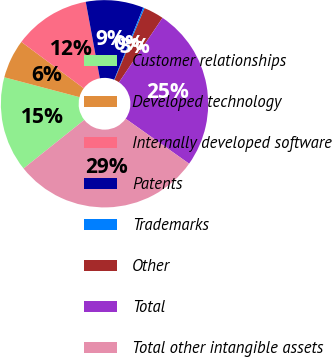Convert chart. <chart><loc_0><loc_0><loc_500><loc_500><pie_chart><fcel>Customer relationships<fcel>Developed technology<fcel>Internally developed software<fcel>Patents<fcel>Trademarks<fcel>Other<fcel>Total<fcel>Total other intangible assets<nl><fcel>14.84%<fcel>6.07%<fcel>11.92%<fcel>8.99%<fcel>0.22%<fcel>3.14%<fcel>25.36%<fcel>29.46%<nl></chart> 